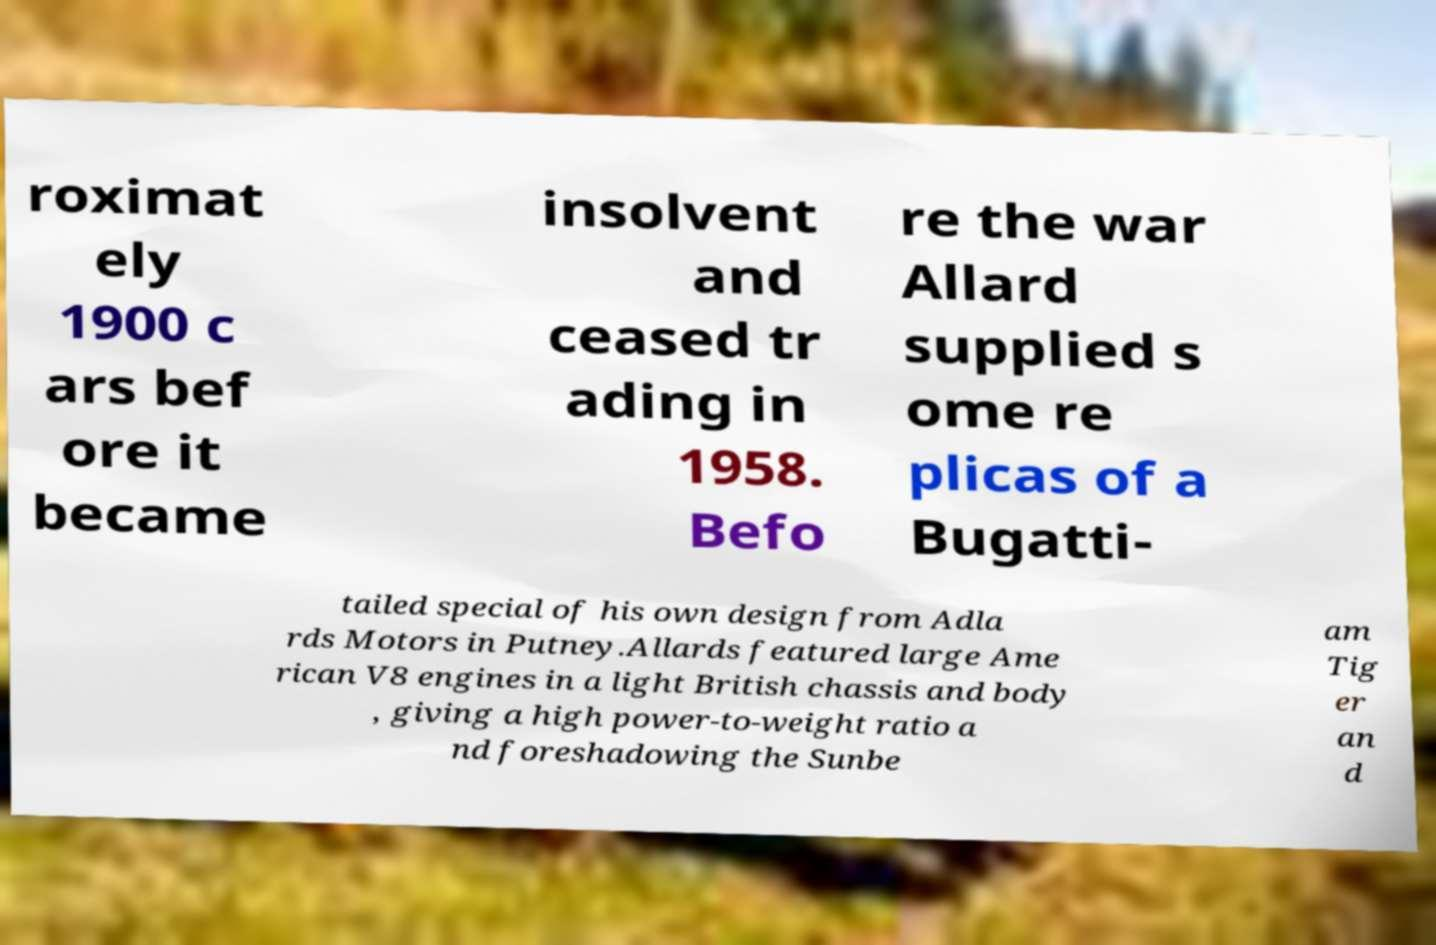There's text embedded in this image that I need extracted. Can you transcribe it verbatim? roximat ely 1900 c ars bef ore it became insolvent and ceased tr ading in 1958. Befo re the war Allard supplied s ome re plicas of a Bugatti- tailed special of his own design from Adla rds Motors in Putney.Allards featured large Ame rican V8 engines in a light British chassis and body , giving a high power-to-weight ratio a nd foreshadowing the Sunbe am Tig er an d 